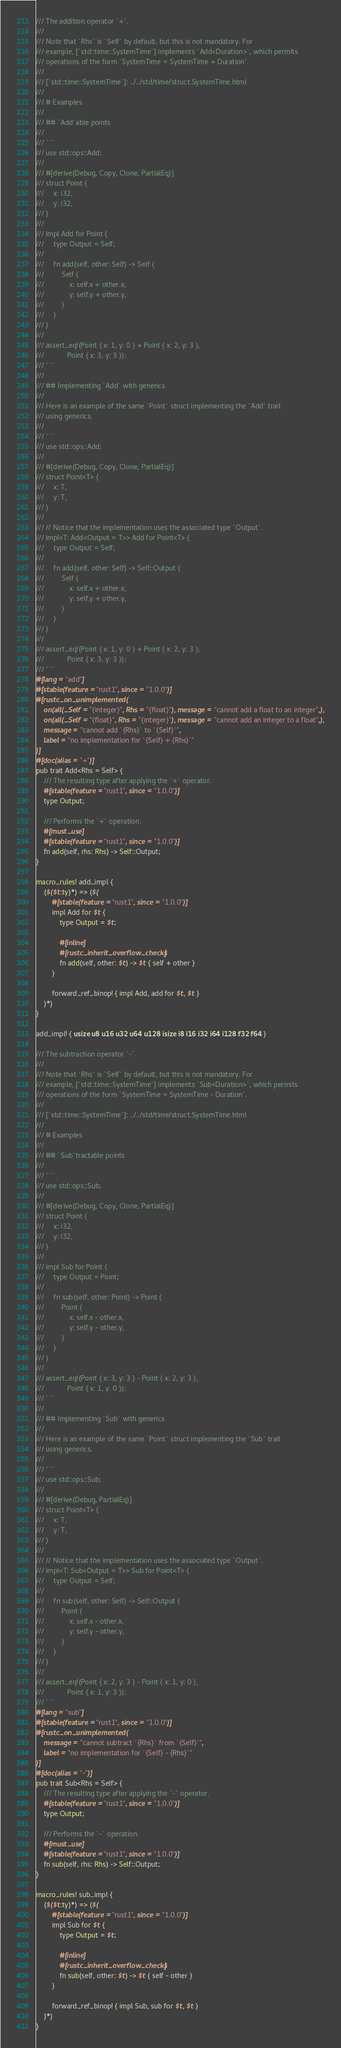Convert code to text. <code><loc_0><loc_0><loc_500><loc_500><_Rust_>/// The addition operator `+`.
///
/// Note that `Rhs` is `Self` by default, but this is not mandatory. For
/// example, [`std::time::SystemTime`] implements `Add<Duration>`, which permits
/// operations of the form `SystemTime = SystemTime + Duration`.
///
/// [`std::time::SystemTime`]: ../../std/time/struct.SystemTime.html
///
/// # Examples
///
/// ## `Add`able points
///
/// ```
/// use std::ops::Add;
///
/// #[derive(Debug, Copy, Clone, PartialEq)]
/// struct Point {
///     x: i32,
///     y: i32,
/// }
///
/// impl Add for Point {
///     type Output = Self;
///
///     fn add(self, other: Self) -> Self {
///         Self {
///             x: self.x + other.x,
///             y: self.y + other.y,
///         }
///     }
/// }
///
/// assert_eq!(Point { x: 1, y: 0 } + Point { x: 2, y: 3 },
///            Point { x: 3, y: 3 });
/// ```
///
/// ## Implementing `Add` with generics
///
/// Here is an example of the same `Point` struct implementing the `Add` trait
/// using generics.
///
/// ```
/// use std::ops::Add;
///
/// #[derive(Debug, Copy, Clone, PartialEq)]
/// struct Point<T> {
///     x: T,
///     y: T,
/// }
///
/// // Notice that the implementation uses the associated type `Output`.
/// impl<T: Add<Output = T>> Add for Point<T> {
///     type Output = Self;
///
///     fn add(self, other: Self) -> Self::Output {
///         Self {
///             x: self.x + other.x,
///             y: self.y + other.y,
///         }
///     }
/// }
///
/// assert_eq!(Point { x: 1, y: 0 } + Point { x: 2, y: 3 },
///            Point { x: 3, y: 3 });
/// ```
#[lang = "add"]
#[stable(feature = "rust1", since = "1.0.0")]
#[rustc_on_unimplemented(
    on(all(_Self = "{integer}", Rhs = "{float}"), message = "cannot add a float to an integer",),
    on(all(_Self = "{float}", Rhs = "{integer}"), message = "cannot add an integer to a float",),
    message = "cannot add `{Rhs}` to `{Self}`",
    label = "no implementation for `{Self} + {Rhs}`"
)]
#[doc(alias = "+")]
pub trait Add<Rhs = Self> {
    /// The resulting type after applying the `+` operator.
    #[stable(feature = "rust1", since = "1.0.0")]
    type Output;

    /// Performs the `+` operation.
    #[must_use]
    #[stable(feature = "rust1", since = "1.0.0")]
    fn add(self, rhs: Rhs) -> Self::Output;
}

macro_rules! add_impl {
    ($($t:ty)*) => ($(
        #[stable(feature = "rust1", since = "1.0.0")]
        impl Add for $t {
            type Output = $t;

            #[inline]
            #[rustc_inherit_overflow_checks]
            fn add(self, other: $t) -> $t { self + other }
        }

        forward_ref_binop! { impl Add, add for $t, $t }
    )*)
}

add_impl! { usize u8 u16 u32 u64 u128 isize i8 i16 i32 i64 i128 f32 f64 }

/// The subtraction operator `-`.
///
/// Note that `Rhs` is `Self` by default, but this is not mandatory. For
/// example, [`std::time::SystemTime`] implements `Sub<Duration>`, which permits
/// operations of the form `SystemTime = SystemTime - Duration`.
///
/// [`std::time::SystemTime`]: ../../std/time/struct.SystemTime.html
///
/// # Examples
///
/// ## `Sub`tractable points
///
/// ```
/// use std::ops::Sub;
///
/// #[derive(Debug, Copy, Clone, PartialEq)]
/// struct Point {
///     x: i32,
///     y: i32,
/// }
///
/// impl Sub for Point {
///     type Output = Point;
///
///     fn sub(self, other: Point) -> Point {
///         Point {
///             x: self.x - other.x,
///             y: self.y - other.y,
///         }
///     }
/// }
///
/// assert_eq!(Point { x: 3, y: 3 } - Point { x: 2, y: 3 },
///            Point { x: 1, y: 0 });
/// ```
///
/// ## Implementing `Sub` with generics
///
/// Here is an example of the same `Point` struct implementing the `Sub` trait
/// using generics.
///
/// ```
/// use std::ops::Sub;
///
/// #[derive(Debug, PartialEq)]
/// struct Point<T> {
///     x: T,
///     y: T,
/// }
///
/// // Notice that the implementation uses the associated type `Output`.
/// impl<T: Sub<Output = T>> Sub for Point<T> {
///     type Output = Self;
///
///     fn sub(self, other: Self) -> Self::Output {
///         Point {
///             x: self.x - other.x,
///             y: self.y - other.y,
///         }
///     }
/// }
///
/// assert_eq!(Point { x: 2, y: 3 } - Point { x: 1, y: 0 },
///            Point { x: 1, y: 3 });
/// ```
#[lang = "sub"]
#[stable(feature = "rust1", since = "1.0.0")]
#[rustc_on_unimplemented(
    message = "cannot subtract `{Rhs}` from `{Self}`",
    label = "no implementation for `{Self} - {Rhs}`"
)]
#[doc(alias = "-")]
pub trait Sub<Rhs = Self> {
    /// The resulting type after applying the `-` operator.
    #[stable(feature = "rust1", since = "1.0.0")]
    type Output;

    /// Performs the `-` operation.
    #[must_use]
    #[stable(feature = "rust1", since = "1.0.0")]
    fn sub(self, rhs: Rhs) -> Self::Output;
}

macro_rules! sub_impl {
    ($($t:ty)*) => ($(
        #[stable(feature = "rust1", since = "1.0.0")]
        impl Sub for $t {
            type Output = $t;

            #[inline]
            #[rustc_inherit_overflow_checks]
            fn sub(self, other: $t) -> $t { self - other }
        }

        forward_ref_binop! { impl Sub, sub for $t, $t }
    )*)
}
</code> 